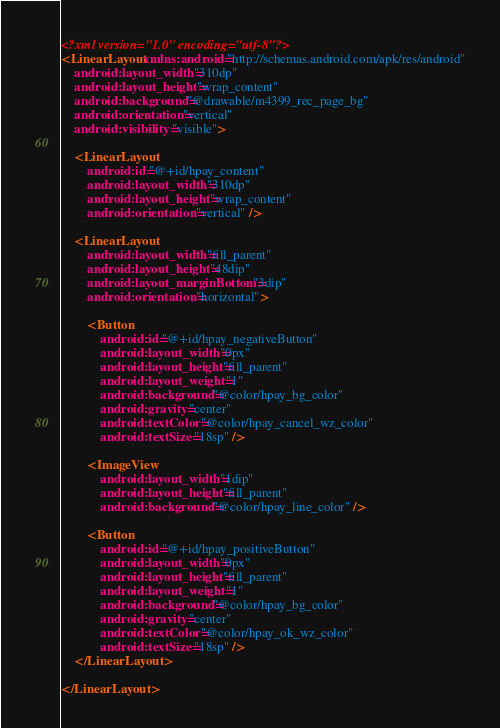<code> <loc_0><loc_0><loc_500><loc_500><_XML_><?xml version="1.0" encoding="utf-8"?>
<LinearLayout xmlns:android="http://schemas.android.com/apk/res/android"
    android:layout_width="310dp"
    android:layout_height="wrap_content"
    android:background="@drawable/m4399_rec_page_bg"
    android:orientation="vertical"
    android:visibility="visible">

    <LinearLayout
        android:id="@+id/hpay_content"
        android:layout_width="310dp"
        android:layout_height="wrap_content"
        android:orientation="vertical" />

    <LinearLayout
        android:layout_width="fill_parent"
        android:layout_height="48dip"
        android:layout_marginBottom="3dip"
        android:orientation="horizontal">

        <Button
            android:id="@+id/hpay_negativeButton"
            android:layout_width="0px"
            android:layout_height="fill_parent"
            android:layout_weight="1"
            android:background="@color/hpay_bg_color"
            android:gravity="center"
            android:textColor="@color/hpay_cancel_wz_color"
            android:textSize="18sp" />

        <ImageView
            android:layout_width="1dip"
            android:layout_height="fill_parent"
            android:background="@color/hpay_line_color" />

        <Button
            android:id="@+id/hpay_positiveButton"
            android:layout_width="0px"
            android:layout_height="fill_parent"
            android:layout_weight="1"
            android:background="@color/hpay_bg_color"
            android:gravity="center"
            android:textColor="@color/hpay_ok_wz_color"
            android:textSize="18sp" />
    </LinearLayout>

</LinearLayout></code> 